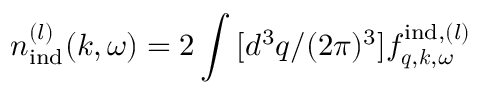<formula> <loc_0><loc_0><loc_500><loc_500>n _ { i n d } ^ { ( l ) } ( k , \omega ) = 2 \int \, [ d ^ { 3 } q / ( 2 \pi ) ^ { 3 } ] f _ { q , k , \omega } ^ { i n d , ( l ) }</formula> 